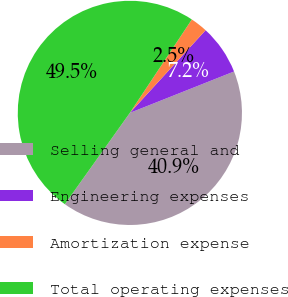Convert chart. <chart><loc_0><loc_0><loc_500><loc_500><pie_chart><fcel>Selling general and<fcel>Engineering expenses<fcel>Amortization expense<fcel>Total operating expenses<nl><fcel>40.87%<fcel>7.18%<fcel>2.48%<fcel>49.48%<nl></chart> 